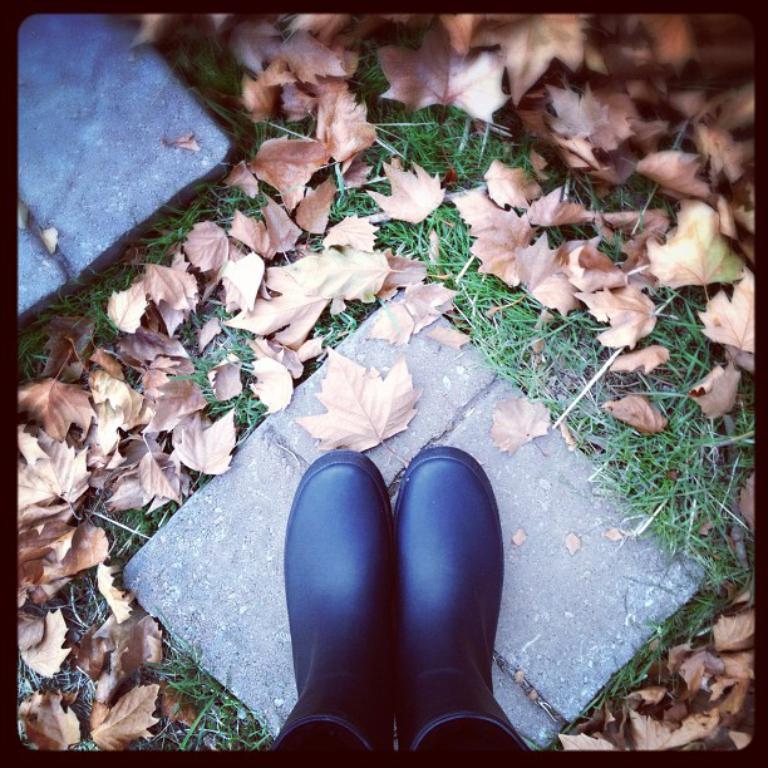In one or two sentences, can you explain what this image depicts? In the foreground of the picture there are two legs of a person. In this picture there are dry leaves, grass and tiles. The picture has black border. 